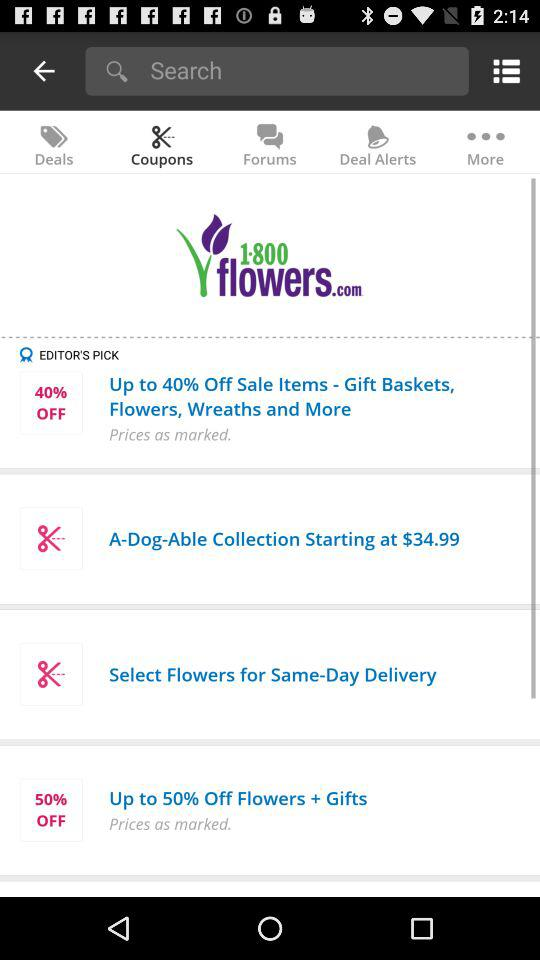What is the selected tab? The selected tab is "Coupons". 